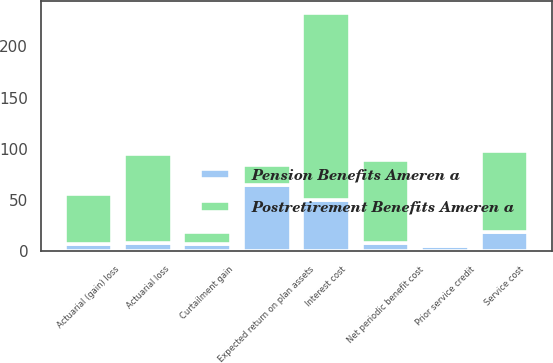<chart> <loc_0><loc_0><loc_500><loc_500><stacked_bar_chart><ecel><fcel>Service cost<fcel>Interest cost<fcel>Expected return on plan assets<fcel>Prior service credit<fcel>Actuarial (gain) loss<fcel>Net periodic benefit cost<fcel>Actuarial loss<fcel>Curtailment gain<nl><fcel>Postretirement Benefits Ameren a<fcel>79<fcel>183<fcel>19<fcel>1<fcel>49<fcel>81<fcel>87<fcel>12<nl><fcel>Pension Benefits Ameren a<fcel>19<fcel>50<fcel>65<fcel>5<fcel>7<fcel>8<fcel>8<fcel>7<nl></chart> 